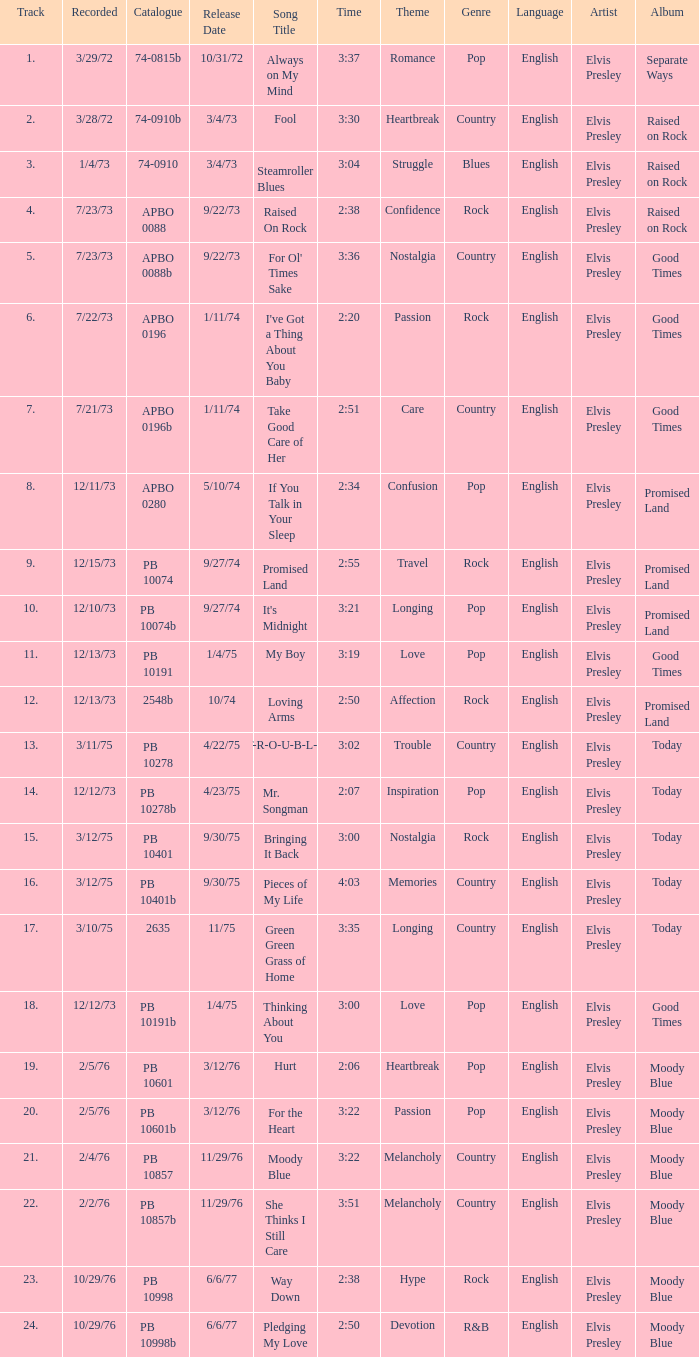Tell me the recorded for time of 2:50 and released date of 6/6/77 with track more than 20 10/29/76. 